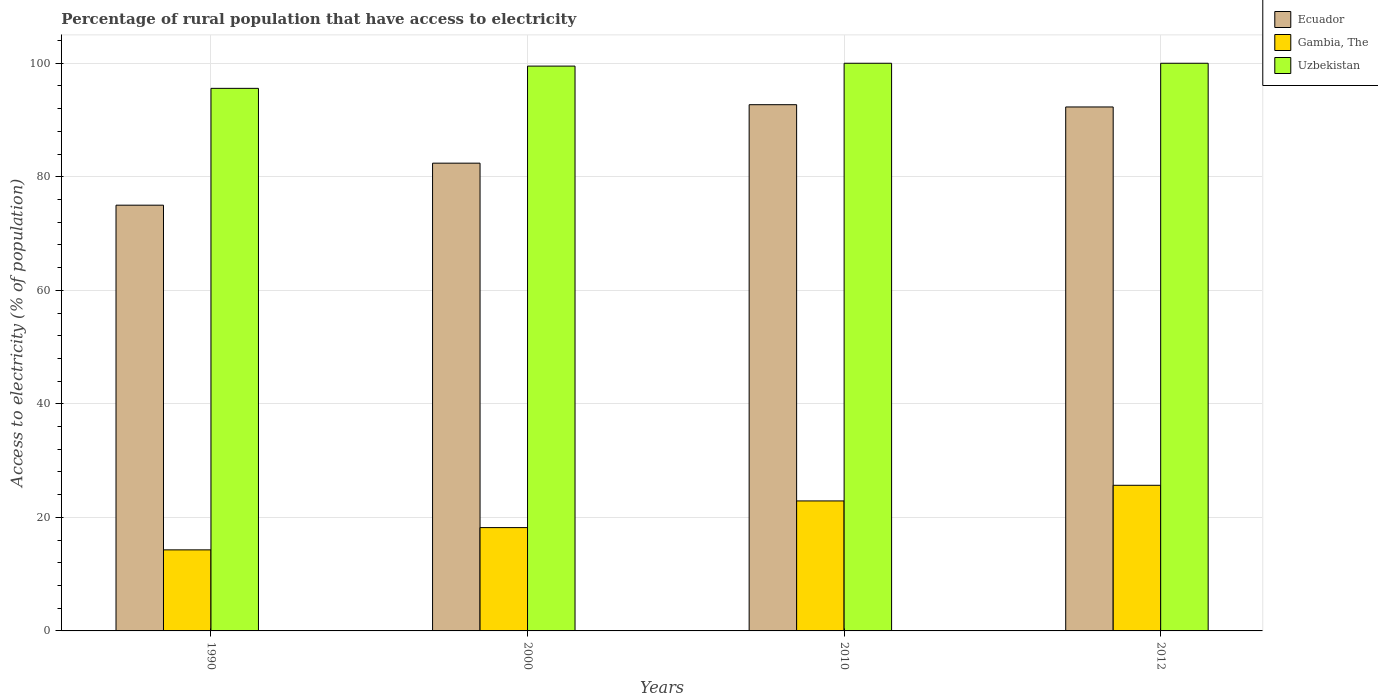How many different coloured bars are there?
Make the answer very short. 3. Are the number of bars on each tick of the X-axis equal?
Offer a terse response. Yes. How many bars are there on the 2nd tick from the left?
Your response must be concise. 3. In how many cases, is the number of bars for a given year not equal to the number of legend labels?
Provide a succinct answer. 0. What is the percentage of rural population that have access to electricity in Gambia, The in 2010?
Give a very brief answer. 22.9. Across all years, what is the maximum percentage of rural population that have access to electricity in Ecuador?
Your response must be concise. 92.7. Across all years, what is the minimum percentage of rural population that have access to electricity in Gambia, The?
Give a very brief answer. 14.28. In which year was the percentage of rural population that have access to electricity in Gambia, The minimum?
Your answer should be compact. 1990. What is the total percentage of rural population that have access to electricity in Uzbekistan in the graph?
Your response must be concise. 395.08. What is the difference between the percentage of rural population that have access to electricity in Ecuador in 1990 and that in 2000?
Give a very brief answer. -7.4. What is the difference between the percentage of rural population that have access to electricity in Gambia, The in 2012 and the percentage of rural population that have access to electricity in Uzbekistan in 1990?
Provide a succinct answer. -69.92. What is the average percentage of rural population that have access to electricity in Gambia, The per year?
Your answer should be compact. 20.26. In the year 2010, what is the difference between the percentage of rural population that have access to electricity in Ecuador and percentage of rural population that have access to electricity in Gambia, The?
Provide a succinct answer. 69.8. In how many years, is the percentage of rural population that have access to electricity in Uzbekistan greater than 20 %?
Make the answer very short. 4. What is the ratio of the percentage of rural population that have access to electricity in Uzbekistan in 2010 to that in 2012?
Make the answer very short. 1. Is the percentage of rural population that have access to electricity in Gambia, The in 1990 less than that in 2000?
Provide a short and direct response. Yes. What is the difference between the highest and the second highest percentage of rural population that have access to electricity in Gambia, The?
Ensure brevity in your answer.  2.75. What is the difference between the highest and the lowest percentage of rural population that have access to electricity in Ecuador?
Give a very brief answer. 17.7. In how many years, is the percentage of rural population that have access to electricity in Ecuador greater than the average percentage of rural population that have access to electricity in Ecuador taken over all years?
Ensure brevity in your answer.  2. Is the sum of the percentage of rural population that have access to electricity in Ecuador in 2010 and 2012 greater than the maximum percentage of rural population that have access to electricity in Gambia, The across all years?
Offer a very short reply. Yes. What does the 1st bar from the left in 2000 represents?
Provide a short and direct response. Ecuador. What does the 1st bar from the right in 2010 represents?
Offer a terse response. Uzbekistan. What is the difference between two consecutive major ticks on the Y-axis?
Provide a short and direct response. 20. Are the values on the major ticks of Y-axis written in scientific E-notation?
Your answer should be very brief. No. Does the graph contain any zero values?
Your answer should be very brief. No. Does the graph contain grids?
Your answer should be very brief. Yes. What is the title of the graph?
Give a very brief answer. Percentage of rural population that have access to electricity. What is the label or title of the Y-axis?
Offer a very short reply. Access to electricity (% of population). What is the Access to electricity (% of population) of Gambia, The in 1990?
Keep it short and to the point. 14.28. What is the Access to electricity (% of population) of Uzbekistan in 1990?
Keep it short and to the point. 95.58. What is the Access to electricity (% of population) of Ecuador in 2000?
Provide a short and direct response. 82.4. What is the Access to electricity (% of population) of Gambia, The in 2000?
Make the answer very short. 18.2. What is the Access to electricity (% of population) of Uzbekistan in 2000?
Keep it short and to the point. 99.5. What is the Access to electricity (% of population) of Ecuador in 2010?
Your answer should be very brief. 92.7. What is the Access to electricity (% of population) of Gambia, The in 2010?
Make the answer very short. 22.9. What is the Access to electricity (% of population) of Uzbekistan in 2010?
Your answer should be very brief. 100. What is the Access to electricity (% of population) in Ecuador in 2012?
Your response must be concise. 92.3. What is the Access to electricity (% of population) in Gambia, The in 2012?
Provide a short and direct response. 25.65. What is the Access to electricity (% of population) in Uzbekistan in 2012?
Your answer should be compact. 100. Across all years, what is the maximum Access to electricity (% of population) in Ecuador?
Make the answer very short. 92.7. Across all years, what is the maximum Access to electricity (% of population) of Gambia, The?
Offer a terse response. 25.65. Across all years, what is the maximum Access to electricity (% of population) of Uzbekistan?
Your response must be concise. 100. Across all years, what is the minimum Access to electricity (% of population) of Ecuador?
Ensure brevity in your answer.  75. Across all years, what is the minimum Access to electricity (% of population) of Gambia, The?
Keep it short and to the point. 14.28. Across all years, what is the minimum Access to electricity (% of population) of Uzbekistan?
Make the answer very short. 95.58. What is the total Access to electricity (% of population) of Ecuador in the graph?
Offer a terse response. 342.4. What is the total Access to electricity (% of population) of Gambia, The in the graph?
Make the answer very short. 81.03. What is the total Access to electricity (% of population) of Uzbekistan in the graph?
Your answer should be very brief. 395.08. What is the difference between the Access to electricity (% of population) in Ecuador in 1990 and that in 2000?
Provide a succinct answer. -7.4. What is the difference between the Access to electricity (% of population) in Gambia, The in 1990 and that in 2000?
Offer a very short reply. -3.92. What is the difference between the Access to electricity (% of population) in Uzbekistan in 1990 and that in 2000?
Provide a short and direct response. -3.92. What is the difference between the Access to electricity (% of population) of Ecuador in 1990 and that in 2010?
Make the answer very short. -17.7. What is the difference between the Access to electricity (% of population) in Gambia, The in 1990 and that in 2010?
Make the answer very short. -8.62. What is the difference between the Access to electricity (% of population) of Uzbekistan in 1990 and that in 2010?
Ensure brevity in your answer.  -4.42. What is the difference between the Access to electricity (% of population) of Ecuador in 1990 and that in 2012?
Provide a succinct answer. -17.3. What is the difference between the Access to electricity (% of population) of Gambia, The in 1990 and that in 2012?
Provide a short and direct response. -11.38. What is the difference between the Access to electricity (% of population) in Uzbekistan in 1990 and that in 2012?
Provide a short and direct response. -4.42. What is the difference between the Access to electricity (% of population) of Ecuador in 2000 and that in 2010?
Ensure brevity in your answer.  -10.3. What is the difference between the Access to electricity (% of population) of Gambia, The in 2000 and that in 2010?
Offer a very short reply. -4.7. What is the difference between the Access to electricity (% of population) of Ecuador in 2000 and that in 2012?
Provide a succinct answer. -9.9. What is the difference between the Access to electricity (% of population) in Gambia, The in 2000 and that in 2012?
Your answer should be very brief. -7.45. What is the difference between the Access to electricity (% of population) of Uzbekistan in 2000 and that in 2012?
Offer a terse response. -0.5. What is the difference between the Access to electricity (% of population) in Ecuador in 2010 and that in 2012?
Provide a short and direct response. 0.4. What is the difference between the Access to electricity (% of population) of Gambia, The in 2010 and that in 2012?
Make the answer very short. -2.75. What is the difference between the Access to electricity (% of population) of Uzbekistan in 2010 and that in 2012?
Keep it short and to the point. 0. What is the difference between the Access to electricity (% of population) in Ecuador in 1990 and the Access to electricity (% of population) in Gambia, The in 2000?
Your answer should be compact. 56.8. What is the difference between the Access to electricity (% of population) in Ecuador in 1990 and the Access to electricity (% of population) in Uzbekistan in 2000?
Ensure brevity in your answer.  -24.5. What is the difference between the Access to electricity (% of population) of Gambia, The in 1990 and the Access to electricity (% of population) of Uzbekistan in 2000?
Make the answer very short. -85.22. What is the difference between the Access to electricity (% of population) in Ecuador in 1990 and the Access to electricity (% of population) in Gambia, The in 2010?
Make the answer very short. 52.1. What is the difference between the Access to electricity (% of population) in Gambia, The in 1990 and the Access to electricity (% of population) in Uzbekistan in 2010?
Your answer should be compact. -85.72. What is the difference between the Access to electricity (% of population) in Ecuador in 1990 and the Access to electricity (% of population) in Gambia, The in 2012?
Your answer should be compact. 49.35. What is the difference between the Access to electricity (% of population) in Ecuador in 1990 and the Access to electricity (% of population) in Uzbekistan in 2012?
Your answer should be compact. -25. What is the difference between the Access to electricity (% of population) of Gambia, The in 1990 and the Access to electricity (% of population) of Uzbekistan in 2012?
Provide a short and direct response. -85.72. What is the difference between the Access to electricity (% of population) of Ecuador in 2000 and the Access to electricity (% of population) of Gambia, The in 2010?
Offer a very short reply. 59.5. What is the difference between the Access to electricity (% of population) of Ecuador in 2000 and the Access to electricity (% of population) of Uzbekistan in 2010?
Make the answer very short. -17.6. What is the difference between the Access to electricity (% of population) of Gambia, The in 2000 and the Access to electricity (% of population) of Uzbekistan in 2010?
Your answer should be very brief. -81.8. What is the difference between the Access to electricity (% of population) in Ecuador in 2000 and the Access to electricity (% of population) in Gambia, The in 2012?
Give a very brief answer. 56.75. What is the difference between the Access to electricity (% of population) in Ecuador in 2000 and the Access to electricity (% of population) in Uzbekistan in 2012?
Provide a short and direct response. -17.6. What is the difference between the Access to electricity (% of population) of Gambia, The in 2000 and the Access to electricity (% of population) of Uzbekistan in 2012?
Offer a terse response. -81.8. What is the difference between the Access to electricity (% of population) in Ecuador in 2010 and the Access to electricity (% of population) in Gambia, The in 2012?
Make the answer very short. 67.05. What is the difference between the Access to electricity (% of population) in Gambia, The in 2010 and the Access to electricity (% of population) in Uzbekistan in 2012?
Give a very brief answer. -77.1. What is the average Access to electricity (% of population) of Ecuador per year?
Offer a terse response. 85.6. What is the average Access to electricity (% of population) in Gambia, The per year?
Keep it short and to the point. 20.26. What is the average Access to electricity (% of population) in Uzbekistan per year?
Your answer should be compact. 98.77. In the year 1990, what is the difference between the Access to electricity (% of population) of Ecuador and Access to electricity (% of population) of Gambia, The?
Offer a very short reply. 60.72. In the year 1990, what is the difference between the Access to electricity (% of population) in Ecuador and Access to electricity (% of population) in Uzbekistan?
Offer a terse response. -20.58. In the year 1990, what is the difference between the Access to electricity (% of population) of Gambia, The and Access to electricity (% of population) of Uzbekistan?
Ensure brevity in your answer.  -81.3. In the year 2000, what is the difference between the Access to electricity (% of population) in Ecuador and Access to electricity (% of population) in Gambia, The?
Your answer should be very brief. 64.2. In the year 2000, what is the difference between the Access to electricity (% of population) in Ecuador and Access to electricity (% of population) in Uzbekistan?
Your answer should be compact. -17.1. In the year 2000, what is the difference between the Access to electricity (% of population) in Gambia, The and Access to electricity (% of population) in Uzbekistan?
Provide a short and direct response. -81.3. In the year 2010, what is the difference between the Access to electricity (% of population) in Ecuador and Access to electricity (% of population) in Gambia, The?
Provide a short and direct response. 69.8. In the year 2010, what is the difference between the Access to electricity (% of population) of Gambia, The and Access to electricity (% of population) of Uzbekistan?
Give a very brief answer. -77.1. In the year 2012, what is the difference between the Access to electricity (% of population) in Ecuador and Access to electricity (% of population) in Gambia, The?
Provide a succinct answer. 66.65. In the year 2012, what is the difference between the Access to electricity (% of population) of Gambia, The and Access to electricity (% of population) of Uzbekistan?
Your answer should be compact. -74.35. What is the ratio of the Access to electricity (% of population) in Ecuador in 1990 to that in 2000?
Your response must be concise. 0.91. What is the ratio of the Access to electricity (% of population) in Gambia, The in 1990 to that in 2000?
Keep it short and to the point. 0.78. What is the ratio of the Access to electricity (% of population) in Uzbekistan in 1990 to that in 2000?
Ensure brevity in your answer.  0.96. What is the ratio of the Access to electricity (% of population) of Ecuador in 1990 to that in 2010?
Provide a succinct answer. 0.81. What is the ratio of the Access to electricity (% of population) of Gambia, The in 1990 to that in 2010?
Ensure brevity in your answer.  0.62. What is the ratio of the Access to electricity (% of population) of Uzbekistan in 1990 to that in 2010?
Your answer should be very brief. 0.96. What is the ratio of the Access to electricity (% of population) of Ecuador in 1990 to that in 2012?
Ensure brevity in your answer.  0.81. What is the ratio of the Access to electricity (% of population) of Gambia, The in 1990 to that in 2012?
Your response must be concise. 0.56. What is the ratio of the Access to electricity (% of population) of Uzbekistan in 1990 to that in 2012?
Your response must be concise. 0.96. What is the ratio of the Access to electricity (% of population) in Gambia, The in 2000 to that in 2010?
Offer a very short reply. 0.79. What is the ratio of the Access to electricity (% of population) in Uzbekistan in 2000 to that in 2010?
Provide a short and direct response. 0.99. What is the ratio of the Access to electricity (% of population) in Ecuador in 2000 to that in 2012?
Make the answer very short. 0.89. What is the ratio of the Access to electricity (% of population) in Gambia, The in 2000 to that in 2012?
Offer a very short reply. 0.71. What is the ratio of the Access to electricity (% of population) of Uzbekistan in 2000 to that in 2012?
Ensure brevity in your answer.  0.99. What is the ratio of the Access to electricity (% of population) in Ecuador in 2010 to that in 2012?
Your answer should be compact. 1. What is the ratio of the Access to electricity (% of population) in Gambia, The in 2010 to that in 2012?
Ensure brevity in your answer.  0.89. What is the ratio of the Access to electricity (% of population) of Uzbekistan in 2010 to that in 2012?
Your answer should be compact. 1. What is the difference between the highest and the second highest Access to electricity (% of population) of Ecuador?
Give a very brief answer. 0.4. What is the difference between the highest and the second highest Access to electricity (% of population) of Gambia, The?
Ensure brevity in your answer.  2.75. What is the difference between the highest and the second highest Access to electricity (% of population) in Uzbekistan?
Ensure brevity in your answer.  0. What is the difference between the highest and the lowest Access to electricity (% of population) of Ecuador?
Your answer should be compact. 17.7. What is the difference between the highest and the lowest Access to electricity (% of population) in Gambia, The?
Your answer should be compact. 11.38. What is the difference between the highest and the lowest Access to electricity (% of population) of Uzbekistan?
Provide a succinct answer. 4.42. 